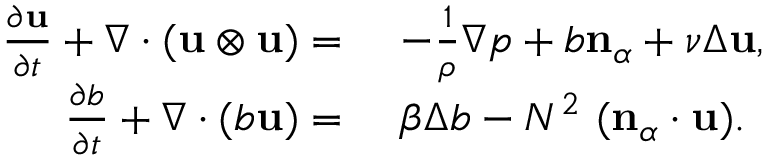Convert formula to latex. <formula><loc_0><loc_0><loc_500><loc_500>\begin{array} { r l } { \frac { \partial u } { \partial t } + \nabla \cdot ( u \otimes u ) = } & { - \frac { 1 } { \rho } \nabla p + b n _ { \alpha } + \nu \Delta u , } \\ { \frac { \partial b } { \partial t } + \nabla \cdot ( b u ) = } & { \beta \Delta b - N ^ { 2 } \ ( n _ { \alpha } \cdot u ) . } \end{array}</formula> 